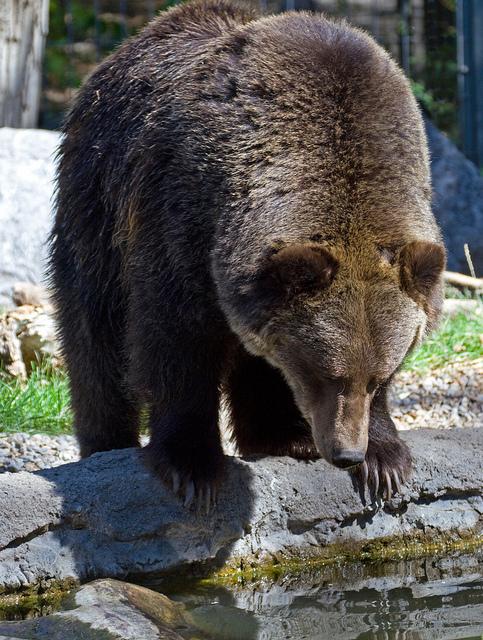Does the bear have a fish in it's mouth?
Keep it brief. No. Is this animal looking up?
Write a very short answer. No. What is in the picture?
Be succinct. Bear. 